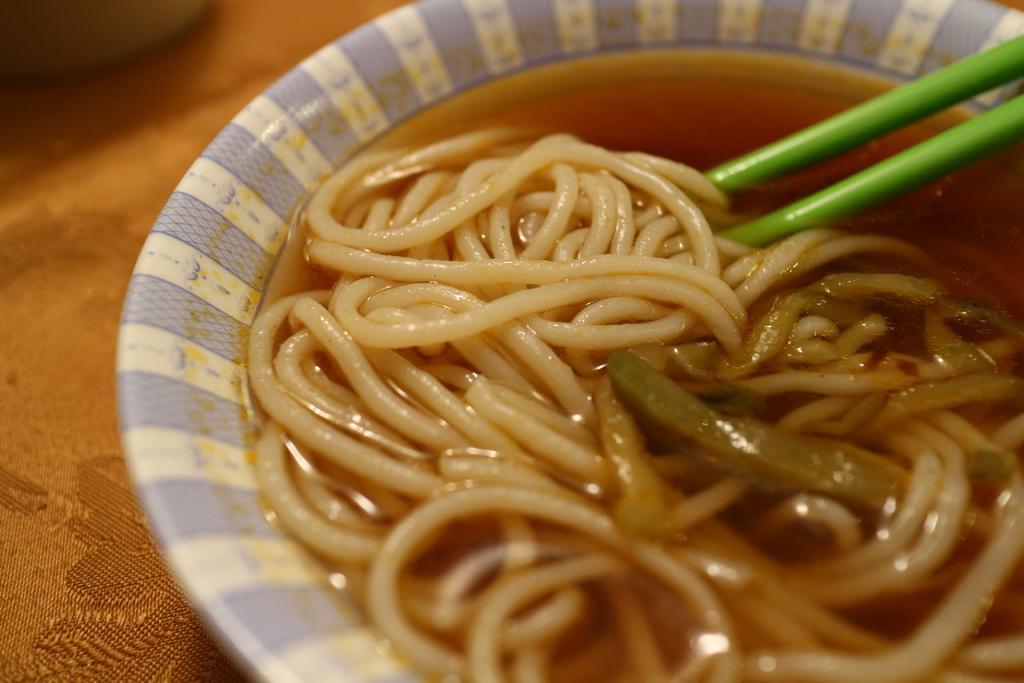Describe this image in one or two sentences. In this picture there were noodles placed in the bowl and some chopsticks here. The bowl is on the table. 